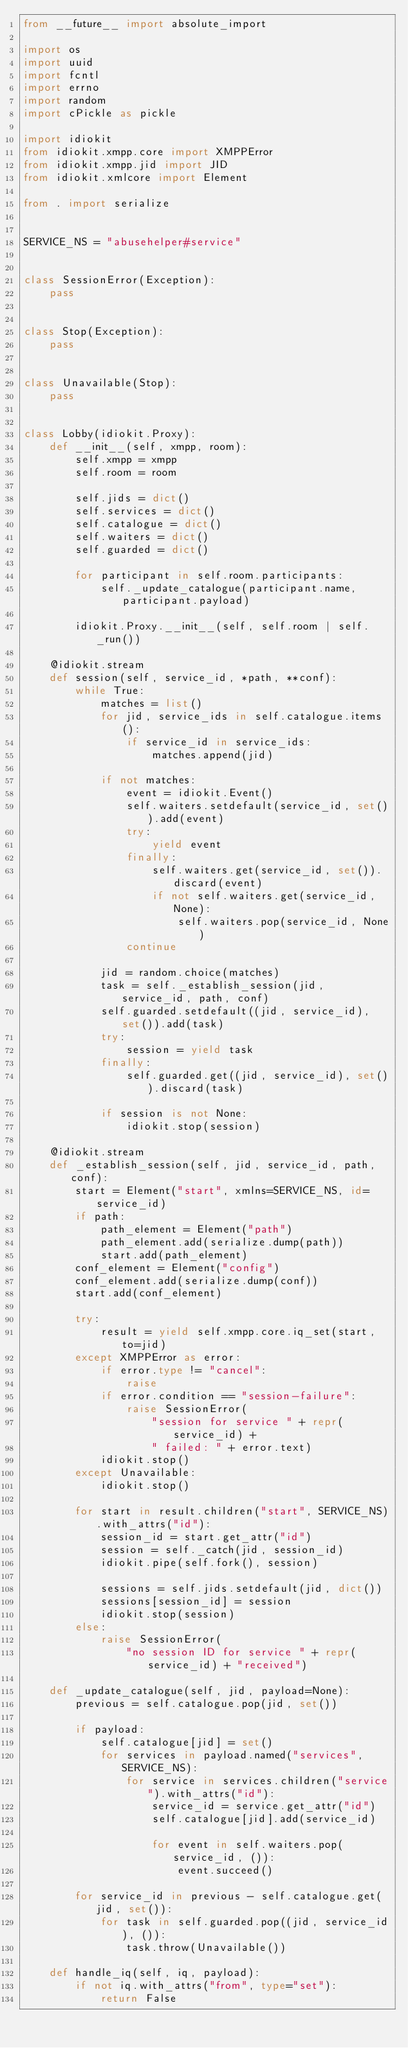Convert code to text. <code><loc_0><loc_0><loc_500><loc_500><_Python_>from __future__ import absolute_import

import os
import uuid
import fcntl
import errno
import random
import cPickle as pickle

import idiokit
from idiokit.xmpp.core import XMPPError
from idiokit.xmpp.jid import JID
from idiokit.xmlcore import Element

from . import serialize


SERVICE_NS = "abusehelper#service"


class SessionError(Exception):
    pass


class Stop(Exception):
    pass


class Unavailable(Stop):
    pass


class Lobby(idiokit.Proxy):
    def __init__(self, xmpp, room):
        self.xmpp = xmpp
        self.room = room

        self.jids = dict()
        self.services = dict()
        self.catalogue = dict()
        self.waiters = dict()
        self.guarded = dict()

        for participant in self.room.participants:
            self._update_catalogue(participant.name, participant.payload)

        idiokit.Proxy.__init__(self, self.room | self._run())

    @idiokit.stream
    def session(self, service_id, *path, **conf):
        while True:
            matches = list()
            for jid, service_ids in self.catalogue.items():
                if service_id in service_ids:
                    matches.append(jid)

            if not matches:
                event = idiokit.Event()
                self.waiters.setdefault(service_id, set()).add(event)
                try:
                    yield event
                finally:
                    self.waiters.get(service_id, set()).discard(event)
                    if not self.waiters.get(service_id, None):
                        self.waiters.pop(service_id, None)
                continue

            jid = random.choice(matches)
            task = self._establish_session(jid, service_id, path, conf)
            self.guarded.setdefault((jid, service_id), set()).add(task)
            try:
                session = yield task
            finally:
                self.guarded.get((jid, service_id), set()).discard(task)

            if session is not None:
                idiokit.stop(session)

    @idiokit.stream
    def _establish_session(self, jid, service_id, path, conf):
        start = Element("start", xmlns=SERVICE_NS, id=service_id)
        if path:
            path_element = Element("path")
            path_element.add(serialize.dump(path))
            start.add(path_element)
        conf_element = Element("config")
        conf_element.add(serialize.dump(conf))
        start.add(conf_element)

        try:
            result = yield self.xmpp.core.iq_set(start, to=jid)
        except XMPPError as error:
            if error.type != "cancel":
                raise
            if error.condition == "session-failure":
                raise SessionError(
                    "session for service " + repr(service_id) +
                    " failed: " + error.text)
            idiokit.stop()
        except Unavailable:
            idiokit.stop()

        for start in result.children("start", SERVICE_NS).with_attrs("id"):
            session_id = start.get_attr("id")
            session = self._catch(jid, session_id)
            idiokit.pipe(self.fork(), session)

            sessions = self.jids.setdefault(jid, dict())
            sessions[session_id] = session
            idiokit.stop(session)
        else:
            raise SessionError(
                "no session ID for service " + repr(service_id) + "received")

    def _update_catalogue(self, jid, payload=None):
        previous = self.catalogue.pop(jid, set())

        if payload:
            self.catalogue[jid] = set()
            for services in payload.named("services", SERVICE_NS):
                for service in services.children("service").with_attrs("id"):
                    service_id = service.get_attr("id")
                    self.catalogue[jid].add(service_id)

                    for event in self.waiters.pop(service_id, ()):
                        event.succeed()

        for service_id in previous - self.catalogue.get(jid, set()):
            for task in self.guarded.pop((jid, service_id), ()):
                task.throw(Unavailable())

    def handle_iq(self, iq, payload):
        if not iq.with_attrs("from", type="set"):
            return False</code> 